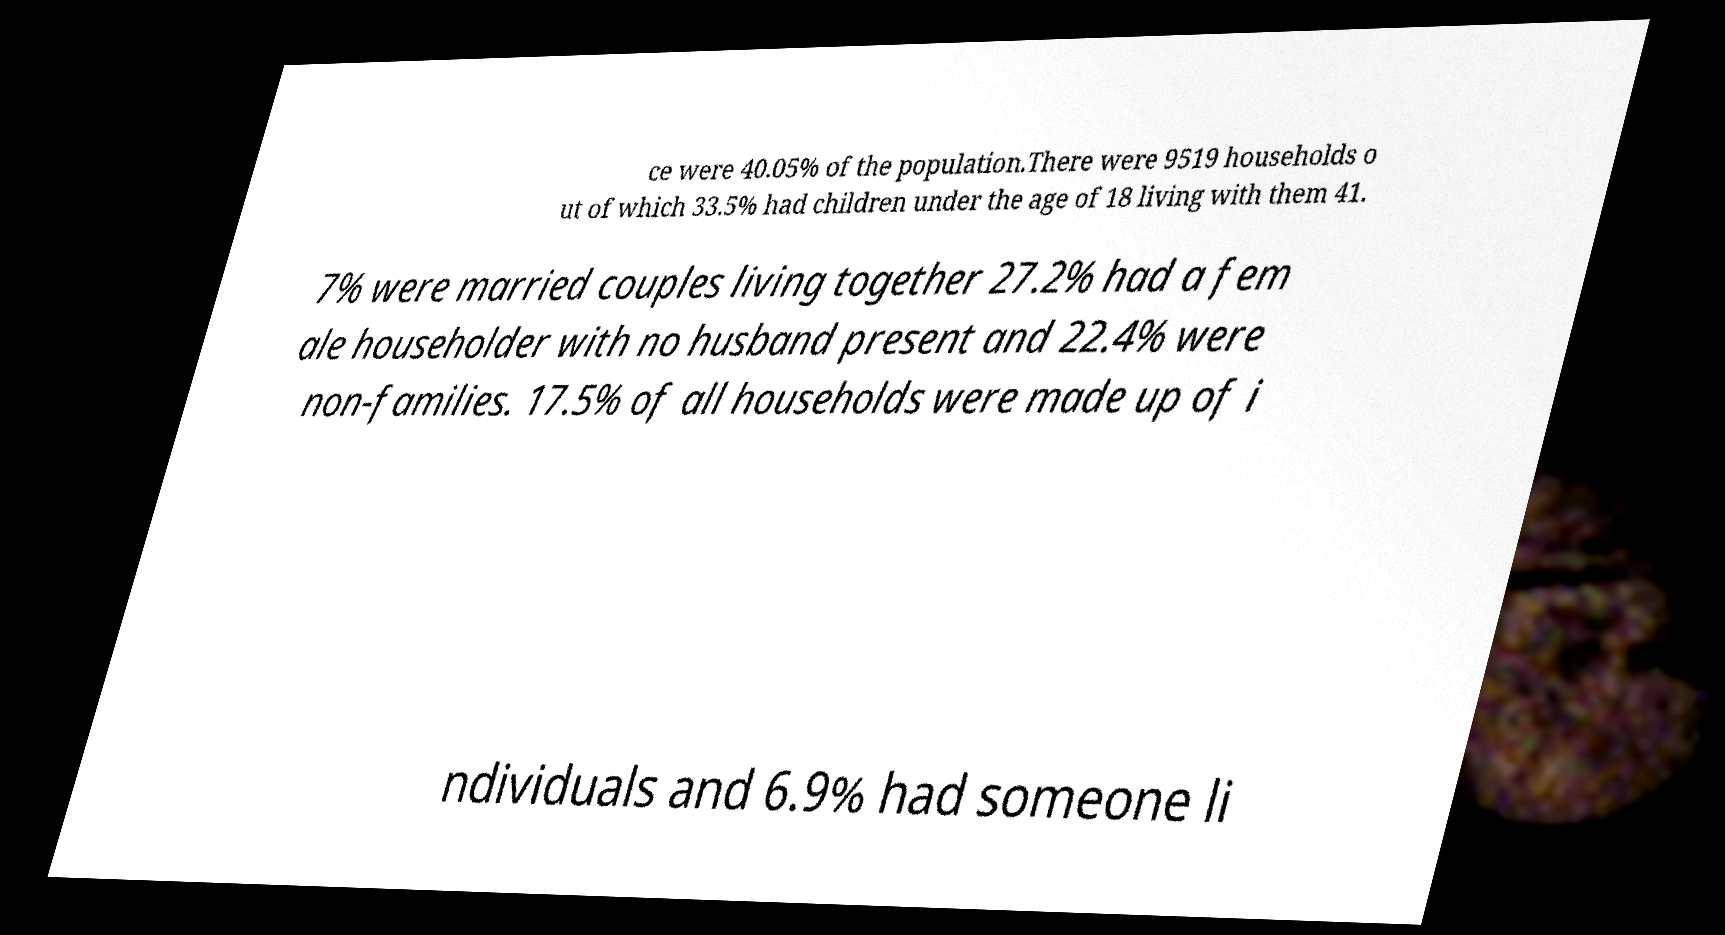Please identify and transcribe the text found in this image. ce were 40.05% of the population.There were 9519 households o ut of which 33.5% had children under the age of 18 living with them 41. 7% were married couples living together 27.2% had a fem ale householder with no husband present and 22.4% were non-families. 17.5% of all households were made up of i ndividuals and 6.9% had someone li 